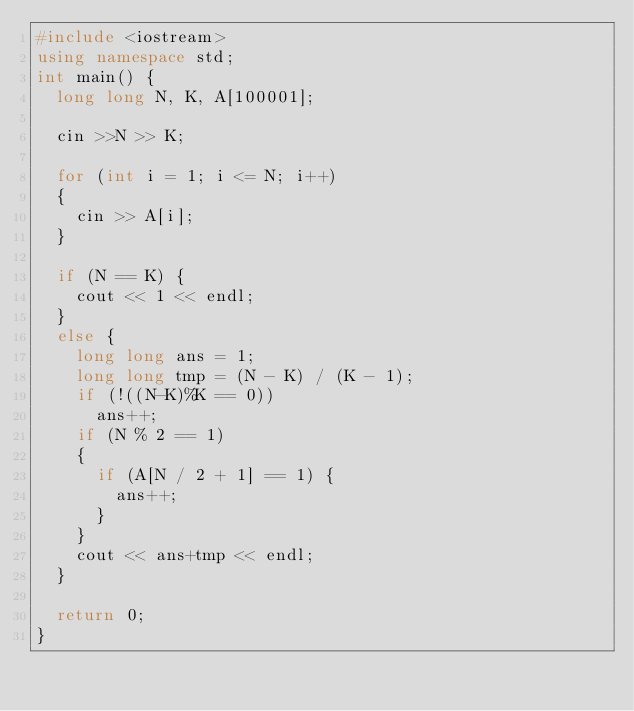Convert code to text. <code><loc_0><loc_0><loc_500><loc_500><_C++_>#include <iostream>
using namespace std;
int main() {
	long long N, K, A[100001];

	cin >>N >> K;

	for (int i = 1; i <= N; i++)
	{
		cin >> A[i];
	}

	if (N == K) {
		cout << 1 << endl;
	}
	else {
		long long ans = 1;
		long long tmp = (N - K) / (K - 1);
		if (!((N-K)%K == 0))
			ans++;
		if (N % 2 == 1)
		{
			if (A[N / 2 + 1] == 1) {
				ans++;
			}
		}
		cout << ans+tmp << endl;
	}

	return 0;
}</code> 